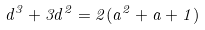Convert formula to latex. <formula><loc_0><loc_0><loc_500><loc_500>d ^ { 3 } + 3 d ^ { 2 } = 2 ( a ^ { 2 } + a + 1 )</formula> 